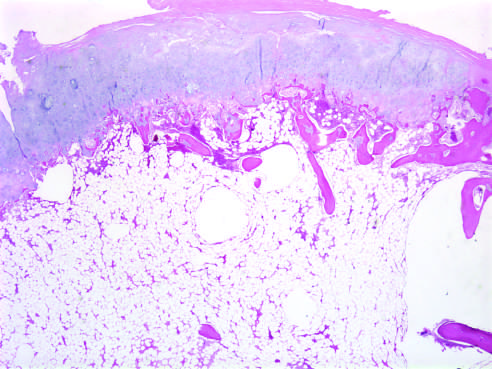does this abnormality have the histologic appearance of disorganized growth plate-like cartilage?
Answer the question using a single word or phrase. No 